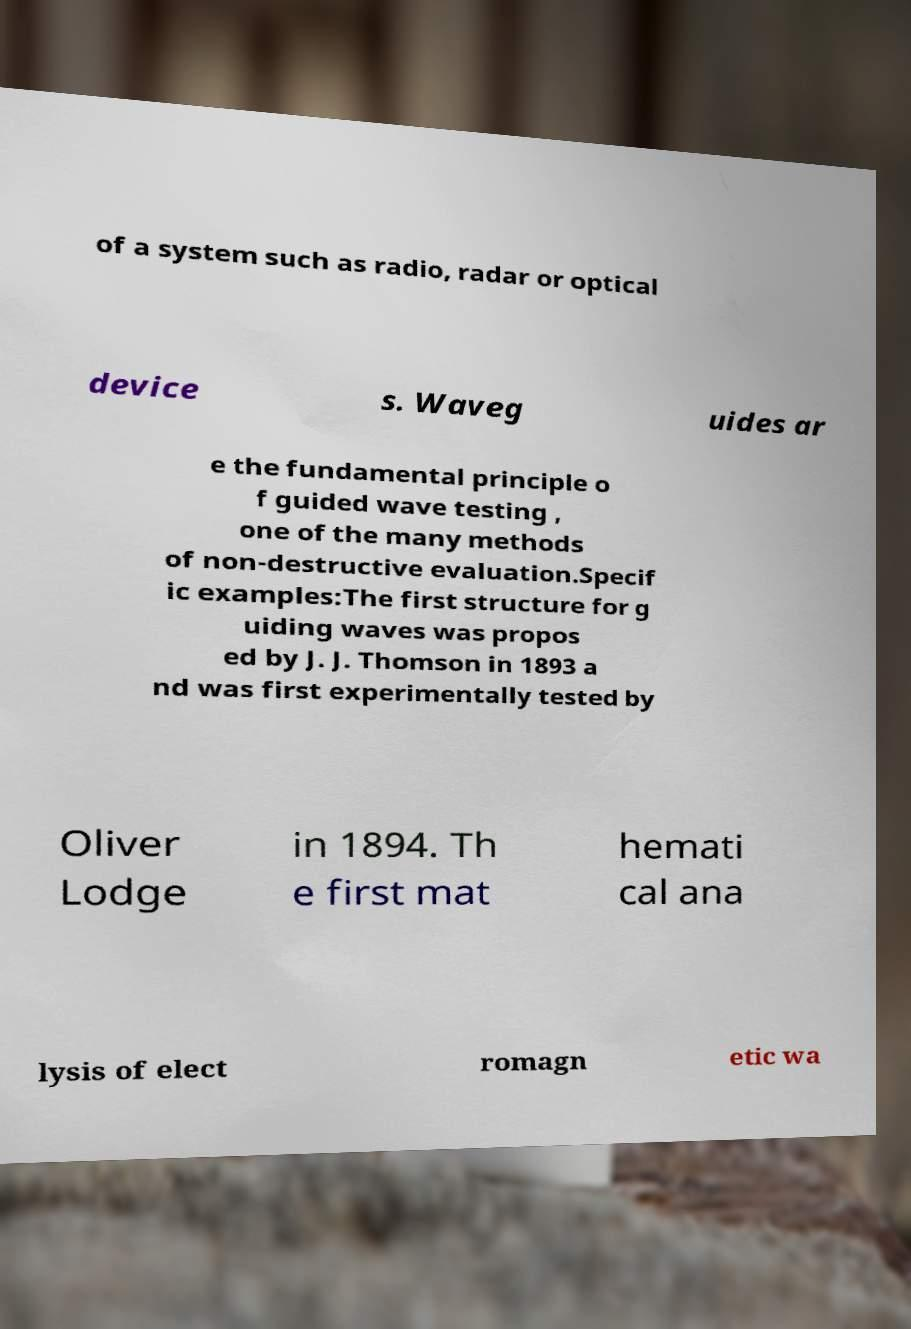Please identify and transcribe the text found in this image. of a system such as radio, radar or optical device s. Waveg uides ar e the fundamental principle o f guided wave testing , one of the many methods of non-destructive evaluation.Specif ic examples:The first structure for g uiding waves was propos ed by J. J. Thomson in 1893 a nd was first experimentally tested by Oliver Lodge in 1894. Th e first mat hemati cal ana lysis of elect romagn etic wa 